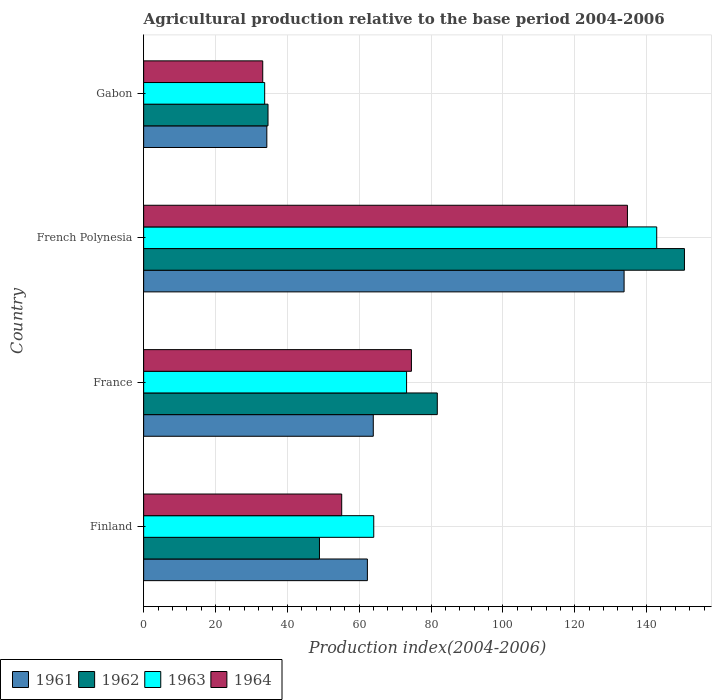How many bars are there on the 4th tick from the top?
Make the answer very short. 4. How many bars are there on the 1st tick from the bottom?
Your response must be concise. 4. What is the label of the 3rd group of bars from the top?
Offer a very short reply. France. In how many cases, is the number of bars for a given country not equal to the number of legend labels?
Ensure brevity in your answer.  0. What is the agricultural production index in 1964 in Gabon?
Offer a terse response. 33.15. Across all countries, what is the maximum agricultural production index in 1961?
Give a very brief answer. 133.74. Across all countries, what is the minimum agricultural production index in 1963?
Ensure brevity in your answer.  33.69. In which country was the agricultural production index in 1964 maximum?
Make the answer very short. French Polynesia. In which country was the agricultural production index in 1962 minimum?
Provide a short and direct response. Gabon. What is the total agricultural production index in 1962 in the graph?
Provide a short and direct response. 315.84. What is the difference between the agricultural production index in 1964 in France and that in French Polynesia?
Provide a short and direct response. -60.13. What is the difference between the agricultural production index in 1963 in France and the agricultural production index in 1964 in French Polynesia?
Make the answer very short. -61.48. What is the average agricultural production index in 1964 per country?
Offer a terse response. 74.37. What is the difference between the agricultural production index in 1962 and agricultural production index in 1961 in French Polynesia?
Provide a succinct answer. 16.8. In how many countries, is the agricultural production index in 1963 greater than 88 ?
Provide a succinct answer. 1. What is the ratio of the agricultural production index in 1962 in Finland to that in Gabon?
Provide a succinct answer. 1.41. Is the agricultural production index in 1963 in Finland less than that in French Polynesia?
Keep it short and to the point. Yes. What is the difference between the highest and the second highest agricultural production index in 1962?
Your answer should be very brief. 68.8. What is the difference between the highest and the lowest agricultural production index in 1962?
Make the answer very short. 115.92. Is the sum of the agricultural production index in 1963 in Finland and France greater than the maximum agricultural production index in 1961 across all countries?
Provide a short and direct response. Yes. What does the 1st bar from the top in French Polynesia represents?
Offer a terse response. 1964. What does the 2nd bar from the bottom in Gabon represents?
Offer a terse response. 1962. Is it the case that in every country, the sum of the agricultural production index in 1963 and agricultural production index in 1962 is greater than the agricultural production index in 1961?
Offer a terse response. Yes. How many bars are there?
Your answer should be compact. 16. Are all the bars in the graph horizontal?
Your response must be concise. Yes. What is the difference between two consecutive major ticks on the X-axis?
Keep it short and to the point. 20. Are the values on the major ticks of X-axis written in scientific E-notation?
Your answer should be compact. No. Does the graph contain any zero values?
Your response must be concise. No. Does the graph contain grids?
Keep it short and to the point. Yes. How many legend labels are there?
Your answer should be compact. 4. How are the legend labels stacked?
Your answer should be compact. Horizontal. What is the title of the graph?
Offer a terse response. Agricultural production relative to the base period 2004-2006. What is the label or title of the X-axis?
Give a very brief answer. Production index(2004-2006). What is the Production index(2004-2006) in 1961 in Finland?
Keep it short and to the point. 62.28. What is the Production index(2004-2006) in 1962 in Finland?
Ensure brevity in your answer.  48.94. What is the Production index(2004-2006) of 1963 in Finland?
Make the answer very short. 64.05. What is the Production index(2004-2006) of 1964 in Finland?
Provide a succinct answer. 55.13. What is the Production index(2004-2006) in 1961 in France?
Your response must be concise. 63.92. What is the Production index(2004-2006) in 1962 in France?
Offer a very short reply. 81.74. What is the Production index(2004-2006) of 1963 in France?
Provide a short and direct response. 73.19. What is the Production index(2004-2006) in 1964 in France?
Make the answer very short. 74.54. What is the Production index(2004-2006) of 1961 in French Polynesia?
Give a very brief answer. 133.74. What is the Production index(2004-2006) of 1962 in French Polynesia?
Offer a terse response. 150.54. What is the Production index(2004-2006) of 1963 in French Polynesia?
Ensure brevity in your answer.  142.82. What is the Production index(2004-2006) in 1964 in French Polynesia?
Make the answer very short. 134.67. What is the Production index(2004-2006) in 1961 in Gabon?
Your answer should be compact. 34.29. What is the Production index(2004-2006) in 1962 in Gabon?
Your answer should be very brief. 34.62. What is the Production index(2004-2006) in 1963 in Gabon?
Offer a very short reply. 33.69. What is the Production index(2004-2006) of 1964 in Gabon?
Ensure brevity in your answer.  33.15. Across all countries, what is the maximum Production index(2004-2006) of 1961?
Your answer should be very brief. 133.74. Across all countries, what is the maximum Production index(2004-2006) in 1962?
Your answer should be very brief. 150.54. Across all countries, what is the maximum Production index(2004-2006) of 1963?
Your response must be concise. 142.82. Across all countries, what is the maximum Production index(2004-2006) of 1964?
Offer a terse response. 134.67. Across all countries, what is the minimum Production index(2004-2006) in 1961?
Provide a succinct answer. 34.29. Across all countries, what is the minimum Production index(2004-2006) in 1962?
Your response must be concise. 34.62. Across all countries, what is the minimum Production index(2004-2006) in 1963?
Keep it short and to the point. 33.69. Across all countries, what is the minimum Production index(2004-2006) in 1964?
Your answer should be very brief. 33.15. What is the total Production index(2004-2006) of 1961 in the graph?
Make the answer very short. 294.23. What is the total Production index(2004-2006) in 1962 in the graph?
Offer a very short reply. 315.84. What is the total Production index(2004-2006) of 1963 in the graph?
Provide a short and direct response. 313.75. What is the total Production index(2004-2006) in 1964 in the graph?
Your answer should be compact. 297.49. What is the difference between the Production index(2004-2006) of 1961 in Finland and that in France?
Your answer should be compact. -1.64. What is the difference between the Production index(2004-2006) in 1962 in Finland and that in France?
Your answer should be compact. -32.8. What is the difference between the Production index(2004-2006) of 1963 in Finland and that in France?
Offer a very short reply. -9.14. What is the difference between the Production index(2004-2006) of 1964 in Finland and that in France?
Offer a terse response. -19.41. What is the difference between the Production index(2004-2006) in 1961 in Finland and that in French Polynesia?
Offer a terse response. -71.46. What is the difference between the Production index(2004-2006) in 1962 in Finland and that in French Polynesia?
Keep it short and to the point. -101.6. What is the difference between the Production index(2004-2006) in 1963 in Finland and that in French Polynesia?
Your answer should be compact. -78.77. What is the difference between the Production index(2004-2006) in 1964 in Finland and that in French Polynesia?
Keep it short and to the point. -79.54. What is the difference between the Production index(2004-2006) in 1961 in Finland and that in Gabon?
Make the answer very short. 27.99. What is the difference between the Production index(2004-2006) of 1962 in Finland and that in Gabon?
Your answer should be compact. 14.32. What is the difference between the Production index(2004-2006) of 1963 in Finland and that in Gabon?
Give a very brief answer. 30.36. What is the difference between the Production index(2004-2006) of 1964 in Finland and that in Gabon?
Provide a short and direct response. 21.98. What is the difference between the Production index(2004-2006) in 1961 in France and that in French Polynesia?
Your answer should be compact. -69.82. What is the difference between the Production index(2004-2006) of 1962 in France and that in French Polynesia?
Ensure brevity in your answer.  -68.8. What is the difference between the Production index(2004-2006) of 1963 in France and that in French Polynesia?
Provide a succinct answer. -69.63. What is the difference between the Production index(2004-2006) in 1964 in France and that in French Polynesia?
Give a very brief answer. -60.13. What is the difference between the Production index(2004-2006) in 1961 in France and that in Gabon?
Your answer should be compact. 29.63. What is the difference between the Production index(2004-2006) in 1962 in France and that in Gabon?
Your response must be concise. 47.12. What is the difference between the Production index(2004-2006) in 1963 in France and that in Gabon?
Provide a short and direct response. 39.5. What is the difference between the Production index(2004-2006) in 1964 in France and that in Gabon?
Keep it short and to the point. 41.39. What is the difference between the Production index(2004-2006) in 1961 in French Polynesia and that in Gabon?
Offer a very short reply. 99.45. What is the difference between the Production index(2004-2006) in 1962 in French Polynesia and that in Gabon?
Your response must be concise. 115.92. What is the difference between the Production index(2004-2006) of 1963 in French Polynesia and that in Gabon?
Offer a terse response. 109.13. What is the difference between the Production index(2004-2006) of 1964 in French Polynesia and that in Gabon?
Offer a terse response. 101.52. What is the difference between the Production index(2004-2006) in 1961 in Finland and the Production index(2004-2006) in 1962 in France?
Your answer should be compact. -19.46. What is the difference between the Production index(2004-2006) of 1961 in Finland and the Production index(2004-2006) of 1963 in France?
Your response must be concise. -10.91. What is the difference between the Production index(2004-2006) of 1961 in Finland and the Production index(2004-2006) of 1964 in France?
Offer a terse response. -12.26. What is the difference between the Production index(2004-2006) of 1962 in Finland and the Production index(2004-2006) of 1963 in France?
Your response must be concise. -24.25. What is the difference between the Production index(2004-2006) in 1962 in Finland and the Production index(2004-2006) in 1964 in France?
Offer a terse response. -25.6. What is the difference between the Production index(2004-2006) of 1963 in Finland and the Production index(2004-2006) of 1964 in France?
Provide a short and direct response. -10.49. What is the difference between the Production index(2004-2006) of 1961 in Finland and the Production index(2004-2006) of 1962 in French Polynesia?
Your answer should be compact. -88.26. What is the difference between the Production index(2004-2006) in 1961 in Finland and the Production index(2004-2006) in 1963 in French Polynesia?
Your answer should be very brief. -80.54. What is the difference between the Production index(2004-2006) of 1961 in Finland and the Production index(2004-2006) of 1964 in French Polynesia?
Your response must be concise. -72.39. What is the difference between the Production index(2004-2006) of 1962 in Finland and the Production index(2004-2006) of 1963 in French Polynesia?
Offer a terse response. -93.88. What is the difference between the Production index(2004-2006) of 1962 in Finland and the Production index(2004-2006) of 1964 in French Polynesia?
Keep it short and to the point. -85.73. What is the difference between the Production index(2004-2006) of 1963 in Finland and the Production index(2004-2006) of 1964 in French Polynesia?
Provide a succinct answer. -70.62. What is the difference between the Production index(2004-2006) in 1961 in Finland and the Production index(2004-2006) in 1962 in Gabon?
Offer a terse response. 27.66. What is the difference between the Production index(2004-2006) in 1961 in Finland and the Production index(2004-2006) in 1963 in Gabon?
Make the answer very short. 28.59. What is the difference between the Production index(2004-2006) in 1961 in Finland and the Production index(2004-2006) in 1964 in Gabon?
Offer a terse response. 29.13. What is the difference between the Production index(2004-2006) in 1962 in Finland and the Production index(2004-2006) in 1963 in Gabon?
Give a very brief answer. 15.25. What is the difference between the Production index(2004-2006) of 1962 in Finland and the Production index(2004-2006) of 1964 in Gabon?
Your answer should be compact. 15.79. What is the difference between the Production index(2004-2006) in 1963 in Finland and the Production index(2004-2006) in 1964 in Gabon?
Ensure brevity in your answer.  30.9. What is the difference between the Production index(2004-2006) in 1961 in France and the Production index(2004-2006) in 1962 in French Polynesia?
Provide a short and direct response. -86.62. What is the difference between the Production index(2004-2006) in 1961 in France and the Production index(2004-2006) in 1963 in French Polynesia?
Provide a short and direct response. -78.9. What is the difference between the Production index(2004-2006) of 1961 in France and the Production index(2004-2006) of 1964 in French Polynesia?
Your answer should be very brief. -70.75. What is the difference between the Production index(2004-2006) of 1962 in France and the Production index(2004-2006) of 1963 in French Polynesia?
Offer a terse response. -61.08. What is the difference between the Production index(2004-2006) of 1962 in France and the Production index(2004-2006) of 1964 in French Polynesia?
Keep it short and to the point. -52.93. What is the difference between the Production index(2004-2006) of 1963 in France and the Production index(2004-2006) of 1964 in French Polynesia?
Provide a short and direct response. -61.48. What is the difference between the Production index(2004-2006) in 1961 in France and the Production index(2004-2006) in 1962 in Gabon?
Ensure brevity in your answer.  29.3. What is the difference between the Production index(2004-2006) of 1961 in France and the Production index(2004-2006) of 1963 in Gabon?
Keep it short and to the point. 30.23. What is the difference between the Production index(2004-2006) in 1961 in France and the Production index(2004-2006) in 1964 in Gabon?
Your answer should be very brief. 30.77. What is the difference between the Production index(2004-2006) of 1962 in France and the Production index(2004-2006) of 1963 in Gabon?
Your response must be concise. 48.05. What is the difference between the Production index(2004-2006) of 1962 in France and the Production index(2004-2006) of 1964 in Gabon?
Provide a short and direct response. 48.59. What is the difference between the Production index(2004-2006) in 1963 in France and the Production index(2004-2006) in 1964 in Gabon?
Ensure brevity in your answer.  40.04. What is the difference between the Production index(2004-2006) in 1961 in French Polynesia and the Production index(2004-2006) in 1962 in Gabon?
Your response must be concise. 99.12. What is the difference between the Production index(2004-2006) of 1961 in French Polynesia and the Production index(2004-2006) of 1963 in Gabon?
Your response must be concise. 100.05. What is the difference between the Production index(2004-2006) of 1961 in French Polynesia and the Production index(2004-2006) of 1964 in Gabon?
Offer a very short reply. 100.59. What is the difference between the Production index(2004-2006) of 1962 in French Polynesia and the Production index(2004-2006) of 1963 in Gabon?
Ensure brevity in your answer.  116.85. What is the difference between the Production index(2004-2006) in 1962 in French Polynesia and the Production index(2004-2006) in 1964 in Gabon?
Make the answer very short. 117.39. What is the difference between the Production index(2004-2006) of 1963 in French Polynesia and the Production index(2004-2006) of 1964 in Gabon?
Make the answer very short. 109.67. What is the average Production index(2004-2006) of 1961 per country?
Offer a very short reply. 73.56. What is the average Production index(2004-2006) of 1962 per country?
Your answer should be very brief. 78.96. What is the average Production index(2004-2006) in 1963 per country?
Offer a very short reply. 78.44. What is the average Production index(2004-2006) of 1964 per country?
Offer a very short reply. 74.37. What is the difference between the Production index(2004-2006) in 1961 and Production index(2004-2006) in 1962 in Finland?
Offer a very short reply. 13.34. What is the difference between the Production index(2004-2006) of 1961 and Production index(2004-2006) of 1963 in Finland?
Offer a very short reply. -1.77. What is the difference between the Production index(2004-2006) of 1961 and Production index(2004-2006) of 1964 in Finland?
Your answer should be compact. 7.15. What is the difference between the Production index(2004-2006) in 1962 and Production index(2004-2006) in 1963 in Finland?
Make the answer very short. -15.11. What is the difference between the Production index(2004-2006) of 1962 and Production index(2004-2006) of 1964 in Finland?
Offer a terse response. -6.19. What is the difference between the Production index(2004-2006) of 1963 and Production index(2004-2006) of 1964 in Finland?
Your answer should be very brief. 8.92. What is the difference between the Production index(2004-2006) of 1961 and Production index(2004-2006) of 1962 in France?
Offer a very short reply. -17.82. What is the difference between the Production index(2004-2006) in 1961 and Production index(2004-2006) in 1963 in France?
Your response must be concise. -9.27. What is the difference between the Production index(2004-2006) in 1961 and Production index(2004-2006) in 1964 in France?
Your answer should be compact. -10.62. What is the difference between the Production index(2004-2006) in 1962 and Production index(2004-2006) in 1963 in France?
Your answer should be compact. 8.55. What is the difference between the Production index(2004-2006) in 1963 and Production index(2004-2006) in 1964 in France?
Give a very brief answer. -1.35. What is the difference between the Production index(2004-2006) of 1961 and Production index(2004-2006) of 1962 in French Polynesia?
Your answer should be compact. -16.8. What is the difference between the Production index(2004-2006) of 1961 and Production index(2004-2006) of 1963 in French Polynesia?
Offer a terse response. -9.08. What is the difference between the Production index(2004-2006) in 1961 and Production index(2004-2006) in 1964 in French Polynesia?
Your answer should be very brief. -0.93. What is the difference between the Production index(2004-2006) of 1962 and Production index(2004-2006) of 1963 in French Polynesia?
Offer a very short reply. 7.72. What is the difference between the Production index(2004-2006) in 1962 and Production index(2004-2006) in 1964 in French Polynesia?
Make the answer very short. 15.87. What is the difference between the Production index(2004-2006) of 1963 and Production index(2004-2006) of 1964 in French Polynesia?
Your answer should be compact. 8.15. What is the difference between the Production index(2004-2006) of 1961 and Production index(2004-2006) of 1962 in Gabon?
Your answer should be very brief. -0.33. What is the difference between the Production index(2004-2006) of 1961 and Production index(2004-2006) of 1963 in Gabon?
Give a very brief answer. 0.6. What is the difference between the Production index(2004-2006) in 1961 and Production index(2004-2006) in 1964 in Gabon?
Provide a succinct answer. 1.14. What is the difference between the Production index(2004-2006) of 1962 and Production index(2004-2006) of 1964 in Gabon?
Offer a very short reply. 1.47. What is the difference between the Production index(2004-2006) in 1963 and Production index(2004-2006) in 1964 in Gabon?
Your response must be concise. 0.54. What is the ratio of the Production index(2004-2006) of 1961 in Finland to that in France?
Your answer should be compact. 0.97. What is the ratio of the Production index(2004-2006) in 1962 in Finland to that in France?
Keep it short and to the point. 0.6. What is the ratio of the Production index(2004-2006) in 1963 in Finland to that in France?
Provide a short and direct response. 0.88. What is the ratio of the Production index(2004-2006) of 1964 in Finland to that in France?
Provide a succinct answer. 0.74. What is the ratio of the Production index(2004-2006) in 1961 in Finland to that in French Polynesia?
Your answer should be very brief. 0.47. What is the ratio of the Production index(2004-2006) in 1962 in Finland to that in French Polynesia?
Your answer should be compact. 0.33. What is the ratio of the Production index(2004-2006) in 1963 in Finland to that in French Polynesia?
Make the answer very short. 0.45. What is the ratio of the Production index(2004-2006) in 1964 in Finland to that in French Polynesia?
Provide a short and direct response. 0.41. What is the ratio of the Production index(2004-2006) of 1961 in Finland to that in Gabon?
Keep it short and to the point. 1.82. What is the ratio of the Production index(2004-2006) of 1962 in Finland to that in Gabon?
Your answer should be compact. 1.41. What is the ratio of the Production index(2004-2006) of 1963 in Finland to that in Gabon?
Keep it short and to the point. 1.9. What is the ratio of the Production index(2004-2006) in 1964 in Finland to that in Gabon?
Offer a very short reply. 1.66. What is the ratio of the Production index(2004-2006) in 1961 in France to that in French Polynesia?
Provide a succinct answer. 0.48. What is the ratio of the Production index(2004-2006) in 1962 in France to that in French Polynesia?
Provide a succinct answer. 0.54. What is the ratio of the Production index(2004-2006) of 1963 in France to that in French Polynesia?
Make the answer very short. 0.51. What is the ratio of the Production index(2004-2006) of 1964 in France to that in French Polynesia?
Keep it short and to the point. 0.55. What is the ratio of the Production index(2004-2006) in 1961 in France to that in Gabon?
Provide a short and direct response. 1.86. What is the ratio of the Production index(2004-2006) in 1962 in France to that in Gabon?
Give a very brief answer. 2.36. What is the ratio of the Production index(2004-2006) in 1963 in France to that in Gabon?
Provide a succinct answer. 2.17. What is the ratio of the Production index(2004-2006) in 1964 in France to that in Gabon?
Your answer should be compact. 2.25. What is the ratio of the Production index(2004-2006) of 1961 in French Polynesia to that in Gabon?
Your response must be concise. 3.9. What is the ratio of the Production index(2004-2006) in 1962 in French Polynesia to that in Gabon?
Your answer should be compact. 4.35. What is the ratio of the Production index(2004-2006) in 1963 in French Polynesia to that in Gabon?
Your response must be concise. 4.24. What is the ratio of the Production index(2004-2006) of 1964 in French Polynesia to that in Gabon?
Make the answer very short. 4.06. What is the difference between the highest and the second highest Production index(2004-2006) of 1961?
Provide a short and direct response. 69.82. What is the difference between the highest and the second highest Production index(2004-2006) of 1962?
Ensure brevity in your answer.  68.8. What is the difference between the highest and the second highest Production index(2004-2006) in 1963?
Provide a short and direct response. 69.63. What is the difference between the highest and the second highest Production index(2004-2006) in 1964?
Make the answer very short. 60.13. What is the difference between the highest and the lowest Production index(2004-2006) of 1961?
Keep it short and to the point. 99.45. What is the difference between the highest and the lowest Production index(2004-2006) of 1962?
Offer a very short reply. 115.92. What is the difference between the highest and the lowest Production index(2004-2006) in 1963?
Your answer should be compact. 109.13. What is the difference between the highest and the lowest Production index(2004-2006) in 1964?
Provide a succinct answer. 101.52. 